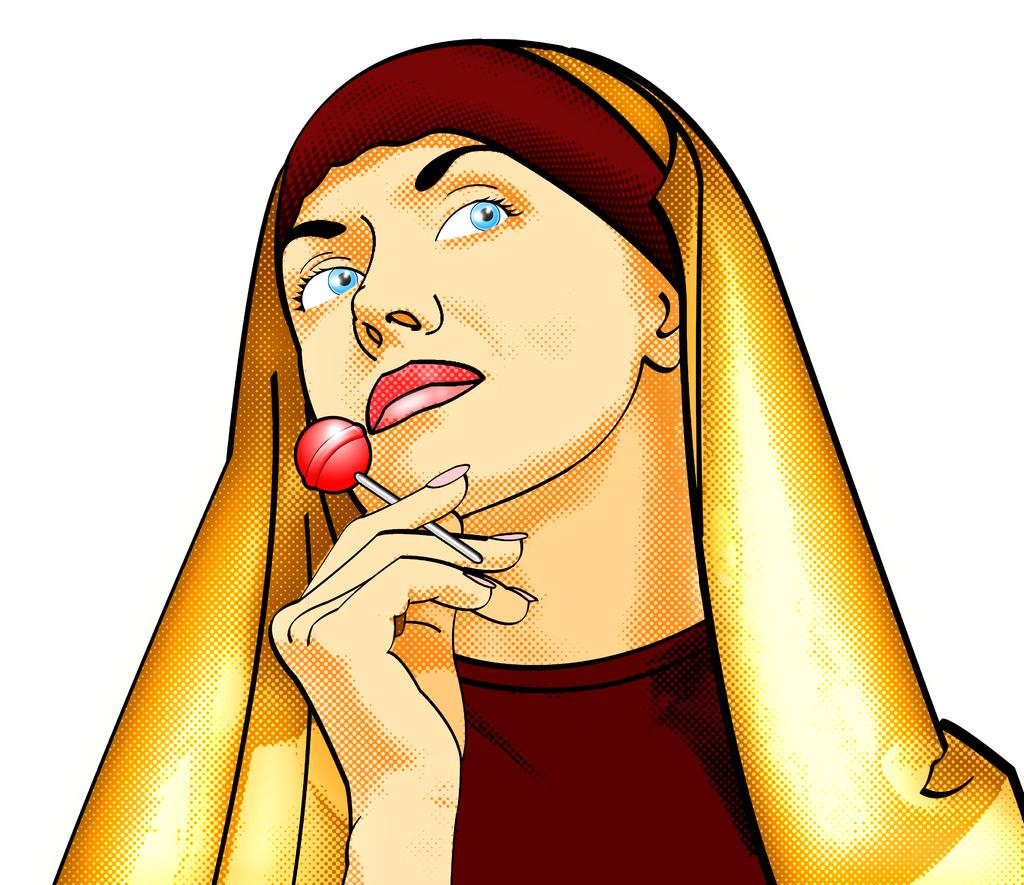What type of picture is in the image? There is an animated picture of a woman in the image. What is the woman holding in her hand? The woman is holding a lollipop in her hand. What color is the background of the image? The background of the image is white. What type of bean is visible in the image? There is no bean present in the image. What sound does the alarm make in the image? There is no alarm present in the image. 